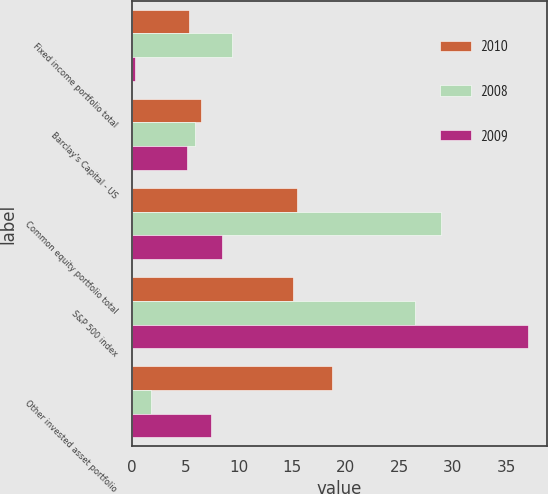<chart> <loc_0><loc_0><loc_500><loc_500><stacked_bar_chart><ecel><fcel>Fixed income portfolio total<fcel>Barclay's Capital - US<fcel>Common equity portfolio total<fcel>S&P 500 index<fcel>Other invested asset portfolio<nl><fcel>2010<fcel>5.3<fcel>6.5<fcel>15.4<fcel>15.1<fcel>18.7<nl><fcel>2008<fcel>9.4<fcel>5.9<fcel>28.9<fcel>26.5<fcel>1.8<nl><fcel>2009<fcel>0.3<fcel>5.2<fcel>8.4<fcel>37<fcel>7.4<nl></chart> 